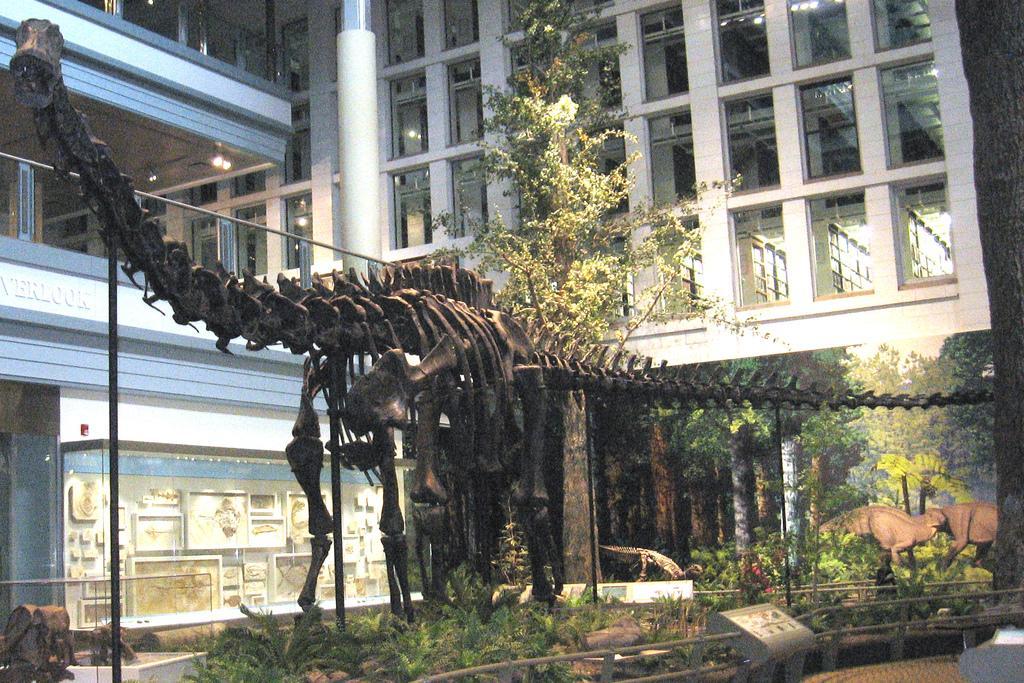How would you summarize this image in a sentence or two? In this picture we can see a skeleton of an animal on the ground, here we can see plants, trees, animals and some objects and in the background we can see a building, lights. 